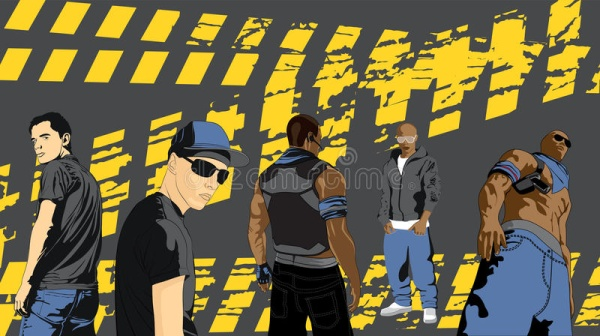Describe the following image. The image depicts a group of five men, each showcasing a distinct style and pose, standing against a striking backdrop of yellow and black stripes. 

On the far left, a man in a black t-shirt and jeans strikes a confident pose with his arms crossed. His casual attire is in contrast to the second man from the left, who sports a black baseball cap and sunglasses, gazing directly towards the viewer with an air of assertiveness. 

In the center, a man dressed in a striped shirt and jeans faces away from the viewer, introducing an element of mystery and intrigue. To his right, a man in a gray hoodie and jeans stands casually with his hands tucked into his pockets, exuding a laid-back vibe. 

Finally, the man on the far right, dressed in a blue tank top and sunglasses, flexes his muscles, emphasizing his physical strength. All five men stand firmly on a gray surface, their unique styles and attitudes contributing to a dynamic and visually engaging composition. 